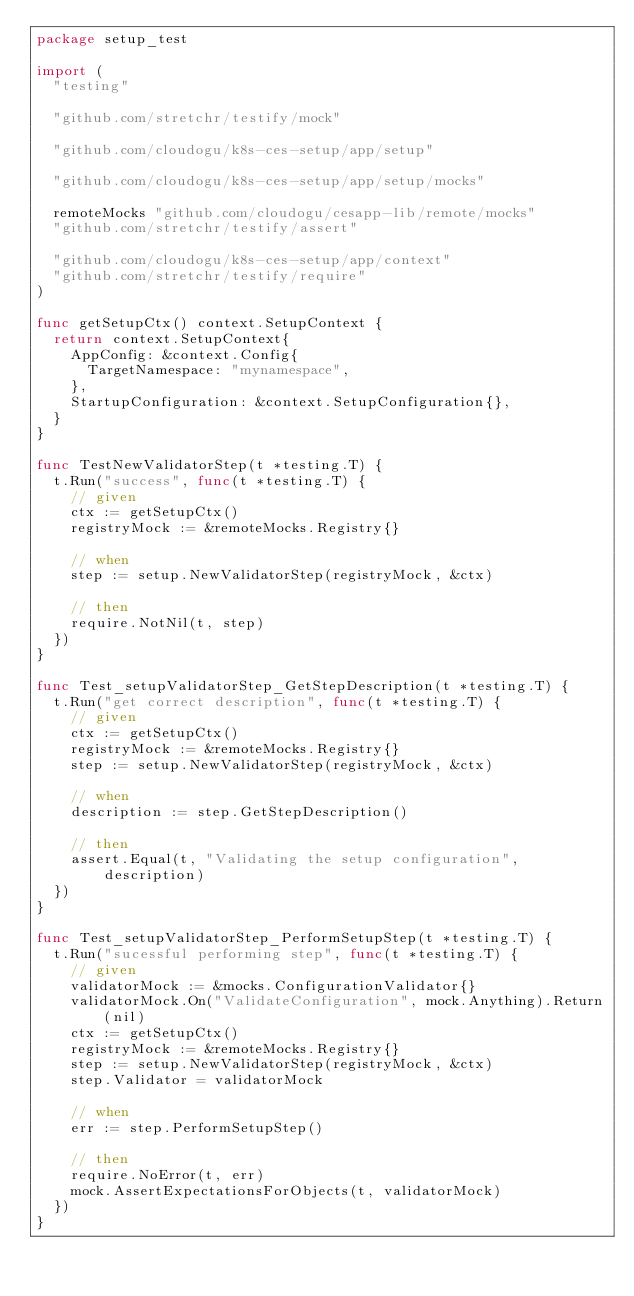Convert code to text. <code><loc_0><loc_0><loc_500><loc_500><_Go_>package setup_test

import (
	"testing"

	"github.com/stretchr/testify/mock"

	"github.com/cloudogu/k8s-ces-setup/app/setup"

	"github.com/cloudogu/k8s-ces-setup/app/setup/mocks"

	remoteMocks "github.com/cloudogu/cesapp-lib/remote/mocks"
	"github.com/stretchr/testify/assert"

	"github.com/cloudogu/k8s-ces-setup/app/context"
	"github.com/stretchr/testify/require"
)

func getSetupCtx() context.SetupContext {
	return context.SetupContext{
		AppConfig: &context.Config{
			TargetNamespace: "mynamespace",
		},
		StartupConfiguration: &context.SetupConfiguration{},
	}
}

func TestNewValidatorStep(t *testing.T) {
	t.Run("success", func(t *testing.T) {
		// given
		ctx := getSetupCtx()
		registryMock := &remoteMocks.Registry{}

		// when
		step := setup.NewValidatorStep(registryMock, &ctx)

		// then
		require.NotNil(t, step)
	})
}

func Test_setupValidatorStep_GetStepDescription(t *testing.T) {
	t.Run("get correct description", func(t *testing.T) {
		// given
		ctx := getSetupCtx()
		registryMock := &remoteMocks.Registry{}
		step := setup.NewValidatorStep(registryMock, &ctx)

		// when
		description := step.GetStepDescription()

		// then
		assert.Equal(t, "Validating the setup configuration", description)
	})
}

func Test_setupValidatorStep_PerformSetupStep(t *testing.T) {
	t.Run("sucessful performing step", func(t *testing.T) {
		// given
		validatorMock := &mocks.ConfigurationValidator{}
		validatorMock.On("ValidateConfiguration", mock.Anything).Return(nil)
		ctx := getSetupCtx()
		registryMock := &remoteMocks.Registry{}
		step := setup.NewValidatorStep(registryMock, &ctx)
		step.Validator = validatorMock

		// when
		err := step.PerformSetupStep()

		// then
		require.NoError(t, err)
		mock.AssertExpectationsForObjects(t, validatorMock)
	})
}
</code> 